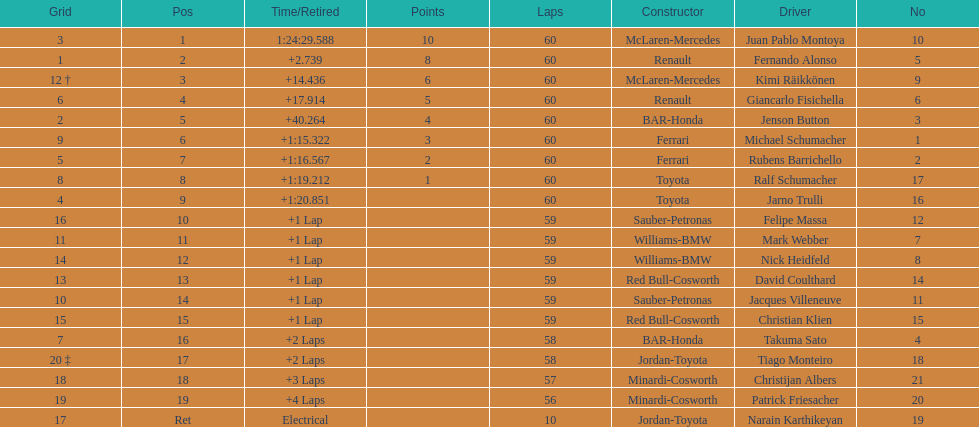What is the number of toyota's on the list? 4. 